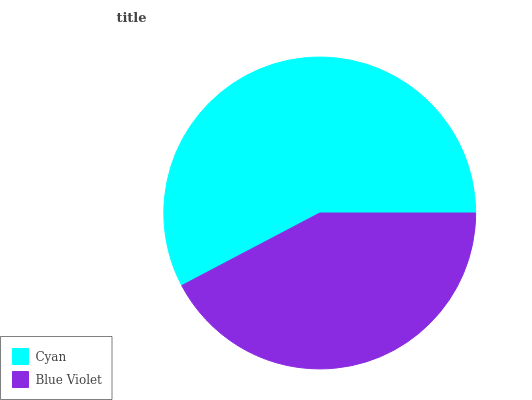Is Blue Violet the minimum?
Answer yes or no. Yes. Is Cyan the maximum?
Answer yes or no. Yes. Is Blue Violet the maximum?
Answer yes or no. No. Is Cyan greater than Blue Violet?
Answer yes or no. Yes. Is Blue Violet less than Cyan?
Answer yes or no. Yes. Is Blue Violet greater than Cyan?
Answer yes or no. No. Is Cyan less than Blue Violet?
Answer yes or no. No. Is Cyan the high median?
Answer yes or no. Yes. Is Blue Violet the low median?
Answer yes or no. Yes. Is Blue Violet the high median?
Answer yes or no. No. Is Cyan the low median?
Answer yes or no. No. 